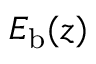<formula> <loc_0><loc_0><loc_500><loc_500>E _ { b } ( z )</formula> 